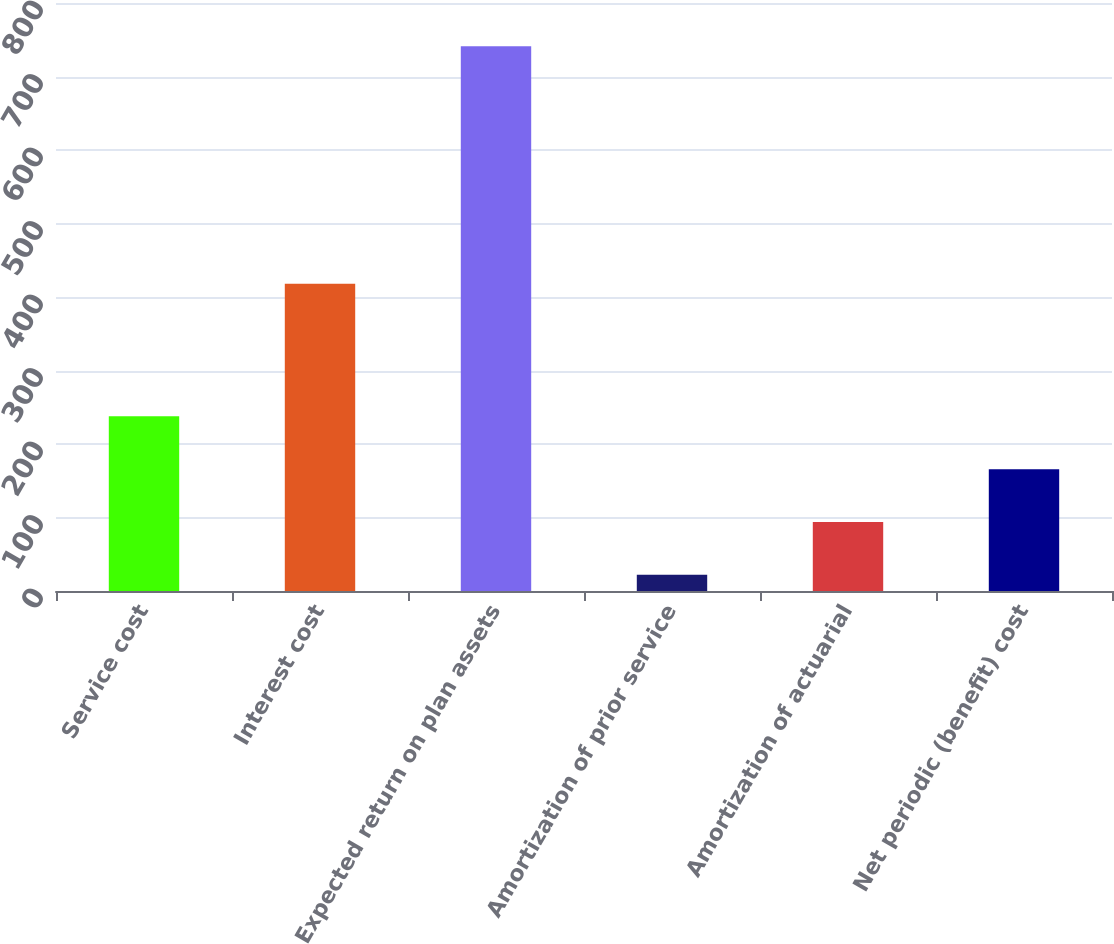Convert chart to OTSL. <chart><loc_0><loc_0><loc_500><loc_500><bar_chart><fcel>Service cost<fcel>Interest cost<fcel>Expected return on plan assets<fcel>Amortization of prior service<fcel>Amortization of actuarial<fcel>Net periodic (benefit) cost<nl><fcel>237.7<fcel>418<fcel>741<fcel>22<fcel>93.9<fcel>165.8<nl></chart> 